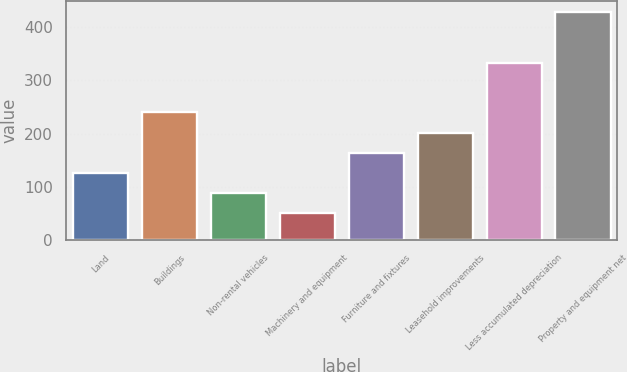Convert chart. <chart><loc_0><loc_0><loc_500><loc_500><bar_chart><fcel>Land<fcel>Buildings<fcel>Non-rental vehicles<fcel>Machinery and equipment<fcel>Furniture and fixtures<fcel>Leasehold improvements<fcel>Less accumulated depreciation<fcel>Property and equipment net<nl><fcel>126.4<fcel>239.5<fcel>88.7<fcel>51<fcel>164.1<fcel>201.8<fcel>333<fcel>428<nl></chart> 